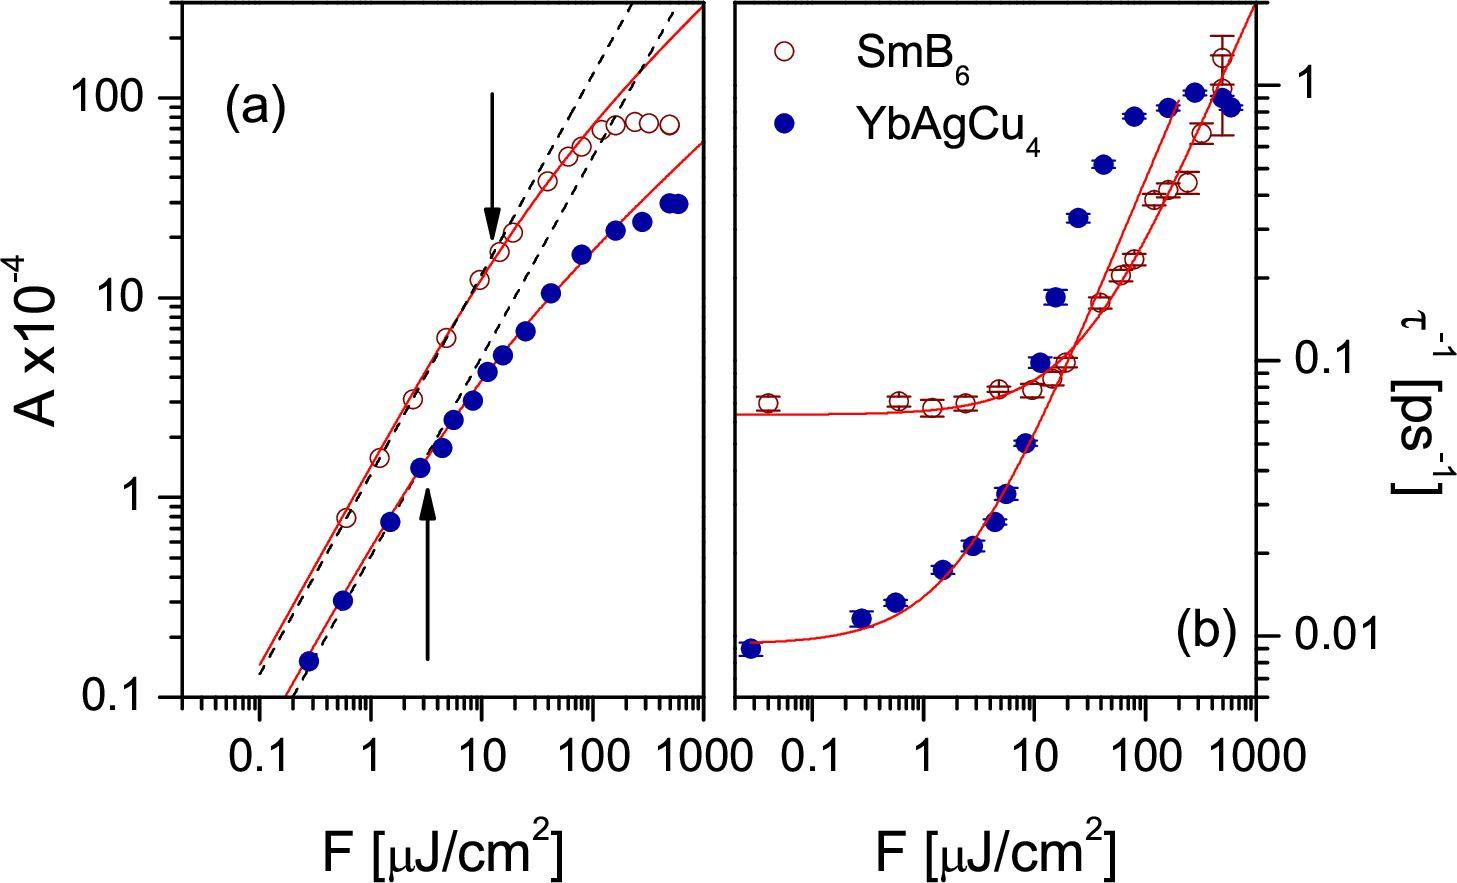What might be the physical significance of the threshold point marked by the arrow in figure (a)? The threshold point highlighted by the arrow in figure (a) could represent a critical point where the physical properties of the material or the conditions of the experiment change fundamentally. For example, it might indicate the onset of a new phase, a phase transition, or the limit of stability of a particular state. Understanding these points is crucial for the application and control of materials and processes involving 'A' and 'F'. 